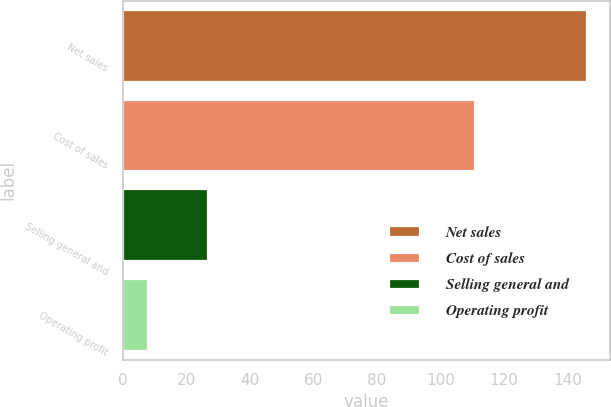Convert chart to OTSL. <chart><loc_0><loc_0><loc_500><loc_500><bar_chart><fcel>Net sales<fcel>Cost of sales<fcel>Selling general and<fcel>Operating profit<nl><fcel>146.1<fcel>111<fcel>27<fcel>8.1<nl></chart> 